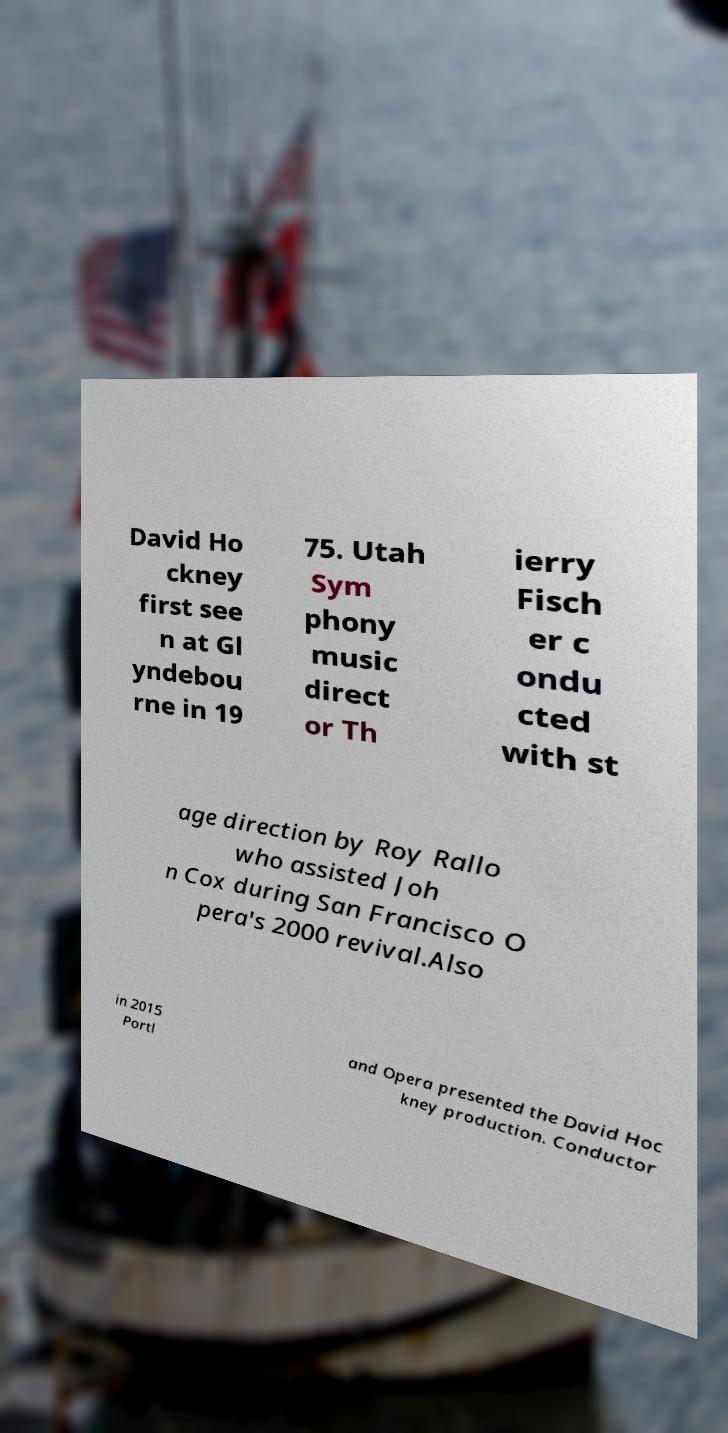Can you read and provide the text displayed in the image?This photo seems to have some interesting text. Can you extract and type it out for me? David Ho ckney first see n at Gl yndebou rne in 19 75. Utah Sym phony music direct or Th ierry Fisch er c ondu cted with st age direction by Roy Rallo who assisted Joh n Cox during San Francisco O pera's 2000 revival.Also in 2015 Portl and Opera presented the David Hoc kney production. Conductor 